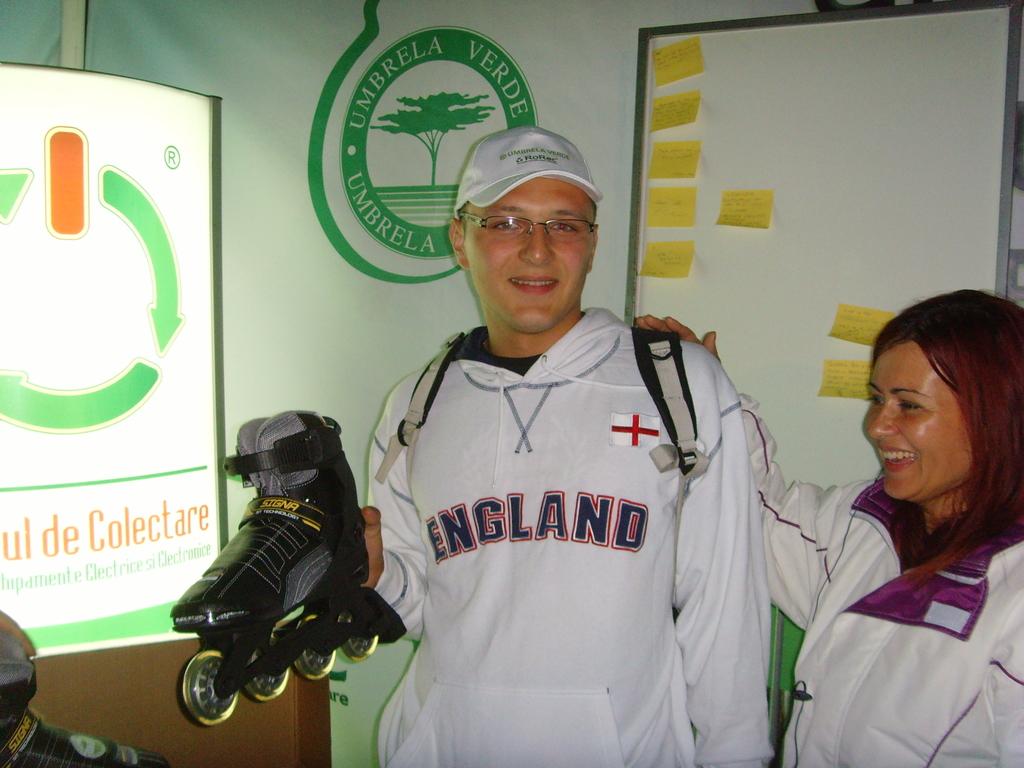Where is the skater from?
Your answer should be very brief. England. What is the word to the side of the mans head?
Make the answer very short. Umbrela. 